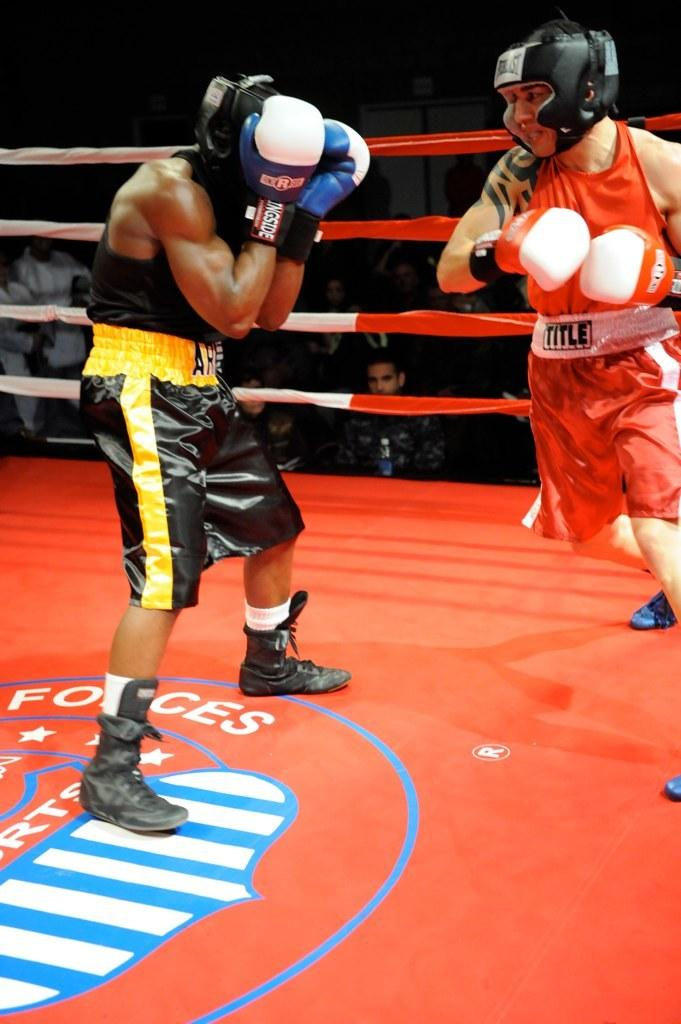Provide a one-sentence caption for the provided image. Two men in a boxing ring with a Forces logo on the floor. 